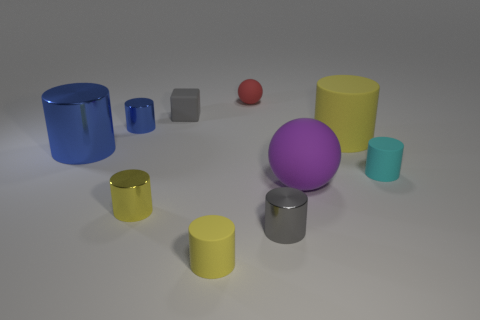Is there anything else that is the same shape as the tiny gray matte thing?
Provide a succinct answer. No. The yellow metallic object is what size?
Provide a short and direct response. Small. What number of purple balls have the same size as the cyan rubber cylinder?
Offer a very short reply. 0. What number of other gray objects are the same shape as the big metallic object?
Your answer should be compact. 1. Are there an equal number of large yellow matte cylinders to the left of the large shiny thing and small yellow metal cylinders?
Make the answer very short. No. What shape is the metal thing that is the same size as the purple matte object?
Your answer should be very brief. Cylinder. Is there a large yellow thing of the same shape as the big blue thing?
Your answer should be compact. Yes. Are there any red things to the right of the yellow rubber cylinder that is behind the tiny matte cylinder that is behind the small yellow matte cylinder?
Offer a terse response. No. Is the number of gray objects that are left of the big purple rubber ball greater than the number of small gray shiny cylinders behind the large yellow thing?
Provide a short and direct response. Yes. What material is the cube that is the same size as the cyan rubber cylinder?
Give a very brief answer. Rubber. 